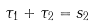Convert formula to latex. <formula><loc_0><loc_0><loc_500><loc_500>\tau _ { 1 } + \tau _ { 2 } = s _ { 2 }</formula> 